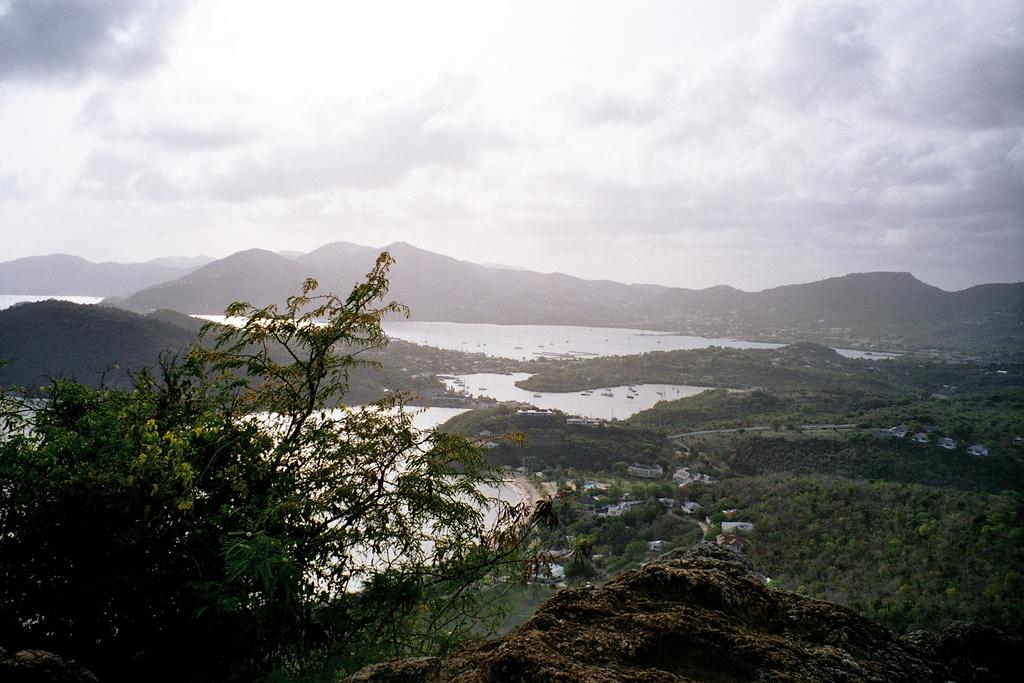What is located on the rock surface in the image? There are plants on a rock surface in the image. What can be seen in the background of the image? There is water visible in the background of the image, and there are plants in the water. What is visible in the distance of the image? There are hills visible in the distance of the image. What is visible at the top of the image? The sky is visible in the image, and clouds are present in the sky. What type of drum can be seen in the image? There is no drum present in the image. What fruit is hanging from the plants on the rock surface? There is no fruit visible in the image; only plants are present on the rock surface. 